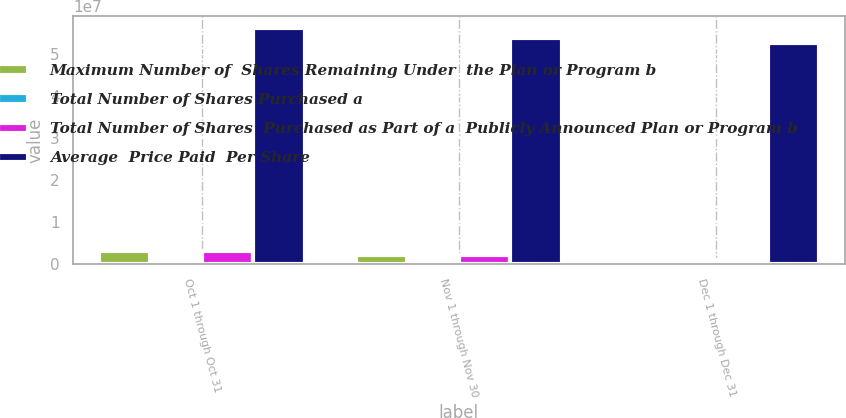<chart> <loc_0><loc_0><loc_500><loc_500><stacked_bar_chart><ecel><fcel>Oct 1 through Oct 31<fcel>Nov 1 through Nov 30<fcel>Dec 1 through Dec 31<nl><fcel>Maximum Number of  Shares Remaining Under  the Plan or Program b<fcel>3.24773e+06<fcel>2.32586e+06<fcel>1.10539e+06<nl><fcel>Total Number of Shares Purchased a<fcel>92.98<fcel>86.61<fcel>77.63<nl><fcel>Total Number of Shares  Purchased as Part of a  Publicly Announced Plan or Program b<fcel>3.22115e+06<fcel>2.32299e+06<fcel>1.10275e+06<nl><fcel>Average  Price Paid  Per Share<fcel>5.60782e+07<fcel>5.37552e+07<fcel>5.26524e+07<nl></chart> 